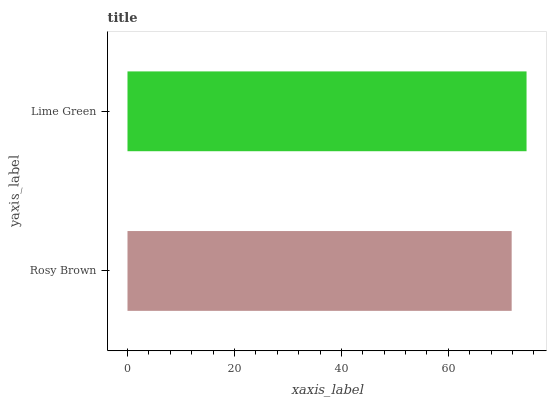Is Rosy Brown the minimum?
Answer yes or no. Yes. Is Lime Green the maximum?
Answer yes or no. Yes. Is Lime Green the minimum?
Answer yes or no. No. Is Lime Green greater than Rosy Brown?
Answer yes or no. Yes. Is Rosy Brown less than Lime Green?
Answer yes or no. Yes. Is Rosy Brown greater than Lime Green?
Answer yes or no. No. Is Lime Green less than Rosy Brown?
Answer yes or no. No. Is Lime Green the high median?
Answer yes or no. Yes. Is Rosy Brown the low median?
Answer yes or no. Yes. Is Rosy Brown the high median?
Answer yes or no. No. Is Lime Green the low median?
Answer yes or no. No. 